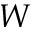<formula> <loc_0><loc_0><loc_500><loc_500>W</formula> 